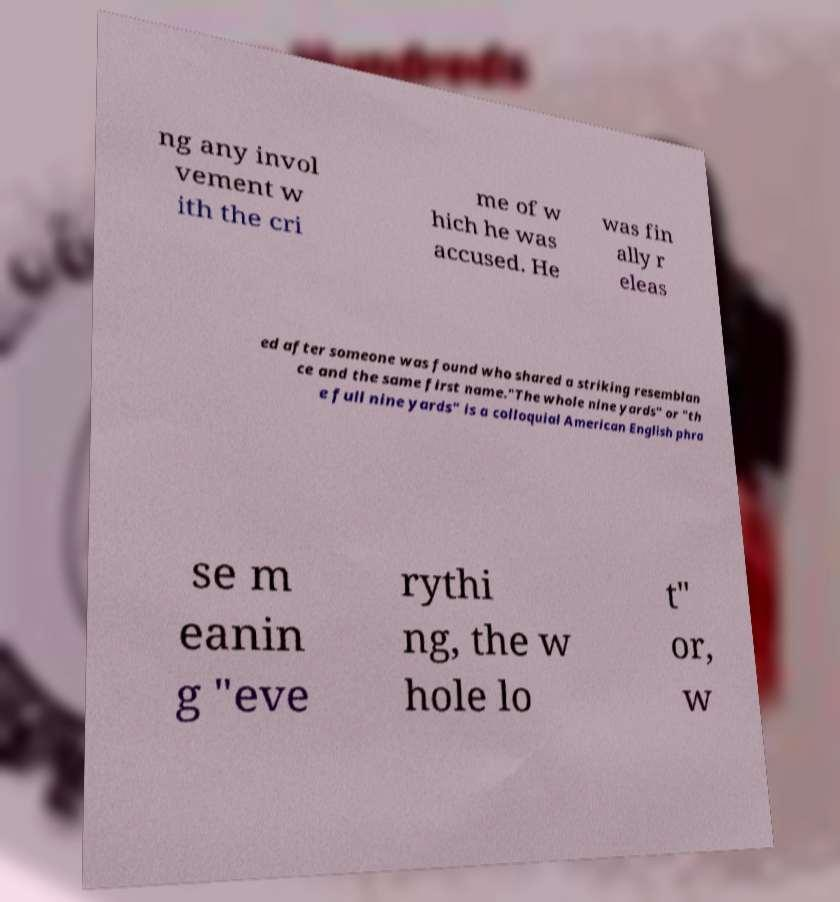I need the written content from this picture converted into text. Can you do that? ng any invol vement w ith the cri me of w hich he was accused. He was fin ally r eleas ed after someone was found who shared a striking resemblan ce and the same first name."The whole nine yards" or "th e full nine yards" is a colloquial American English phra se m eanin g "eve rythi ng, the w hole lo t" or, w 